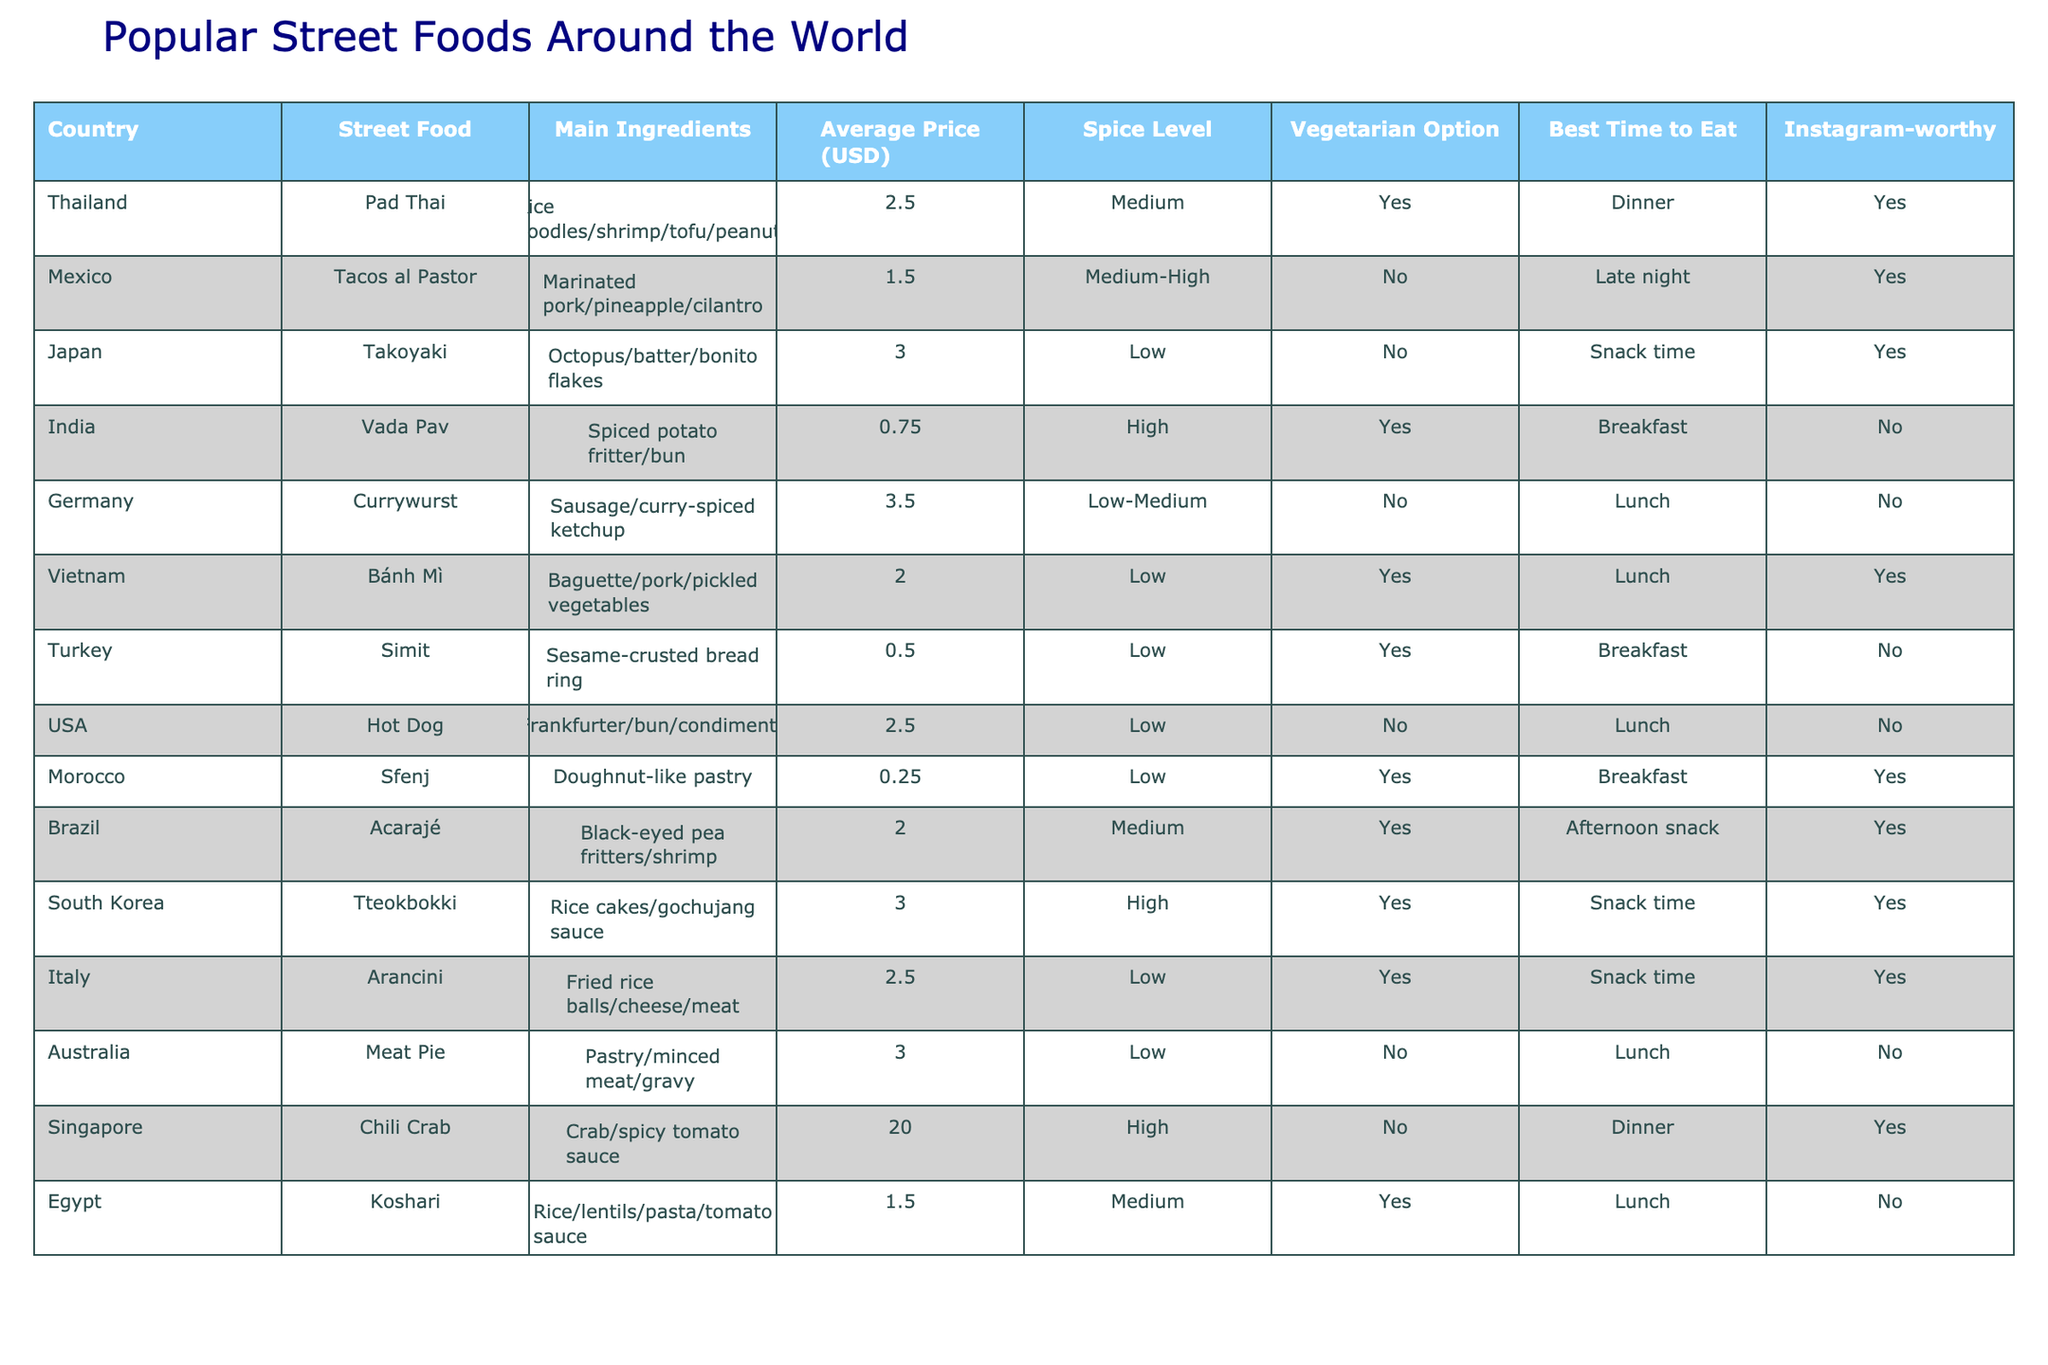What is the most expensive street food listed in the table? The most expensive street food in the table is Chili Crab from Singapore, which has an average price of $20.00. We can find this by scanning the Average Price column for the highest value.
Answer: Chili Crab Which street food has a vegetarian option and costs less than $2? The street food that meets both criteria is Sfenj from Morocco, which costs $0.25 and has a vegetarian option. We can identify this by filtering the Street Food options for those that are vegetarian and checking their prices.
Answer: Sfenj How many street foods on the list are spicy (High or Medium spice level)? There are a total of 6 street foods that are considered spicy: Pad Thai, Tacos al Pastor, Vada Pav, Acarajé, Tteokbokki, and Chili Crab. We can find this by counting the entries classified as High or Medium spice level in the Spice Level column.
Answer: 6 Which country has a street food option that is best for breakfast and is vegetarian? The country with a street food option that is best for breakfast and vegetarian is Turkey with its Simit, as it is specifically stated as a breakfast food and has a vegetarian option. This can be determined by looking for items classified under Breakfast in the Best Time to Eat column while also checking for the Vegetarian Option.
Answer: Turkey What is the average price of vegetarian street foods in the table? To find the average price of vegetarian street foods, we first identify the vegetarian options: Pad Thai, Vada Pav, Bánh Mì, Simit, Sfenj, Acarajé, Tteokbokki, and Arancini. Their prices are $2.50, $0.75, $2.00, $0.50, $0.25, $2.00, $3.00, and $2.50 respectively. Adding these prices gives us a total of $13.50. Since there are 8 items, the average price is $13.50 divided by 8, which equals $1.6875.
Answer: $1.69 How many street foods can be eaten as a late-night snack? There are 2 street foods that are noted as suitable for eating late at night: Tacos al Pastor from Mexico and the only item that matches late-night is not particularly a traditional snack, therefore, only Tacos al Pastor is the option. This is found by filtering the Best Time to Eat for entries labelled as Late night.
Answer: 1 